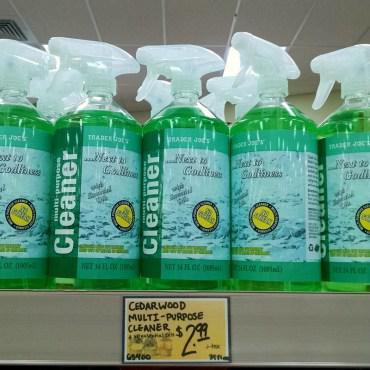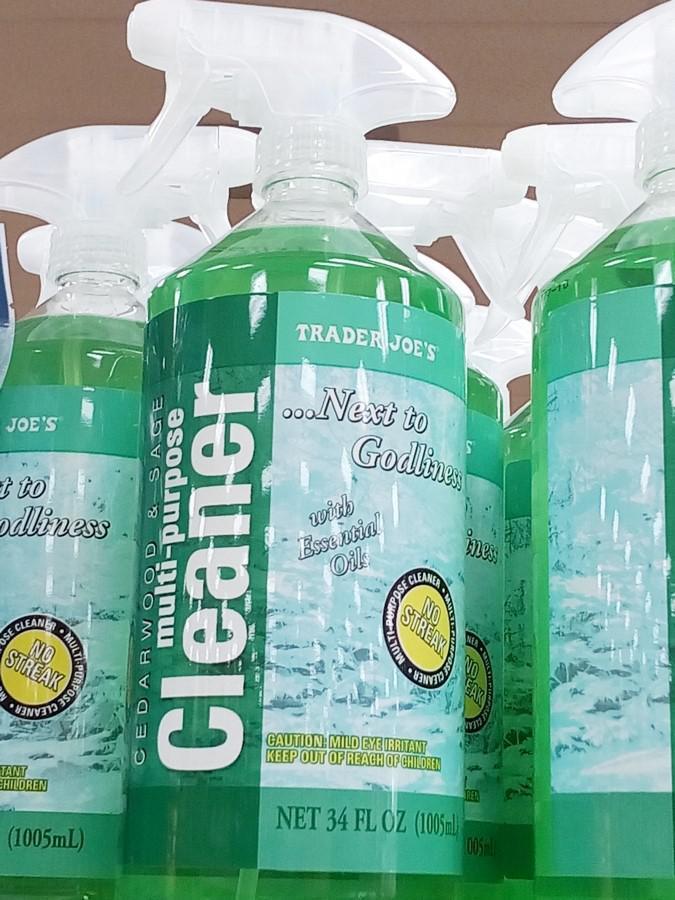The first image is the image on the left, the second image is the image on the right. For the images displayed, is the sentence "There is a bottle with a squeeze trigger in the image on the right" factually correct? Answer yes or no. Yes. The first image is the image on the left, the second image is the image on the right. Given the left and right images, does the statement "There is at least one spray bottle that contains multi purpose cleaner." hold true? Answer yes or no. Yes. 